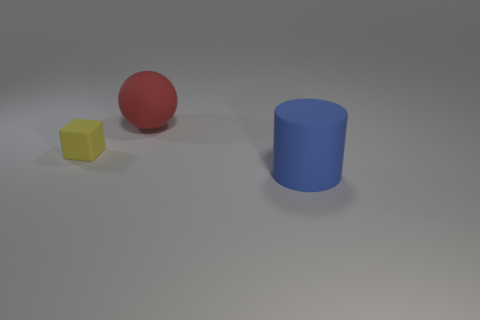Add 2 purple matte spheres. How many objects exist? 5 Subtract 0 purple cubes. How many objects are left? 3 Subtract all cylinders. How many objects are left? 2 Subtract all yellow cylinders. How many purple blocks are left? 0 Subtract all rubber blocks. Subtract all matte balls. How many objects are left? 1 Add 1 big matte balls. How many big matte balls are left? 2 Add 2 tiny objects. How many tiny objects exist? 3 